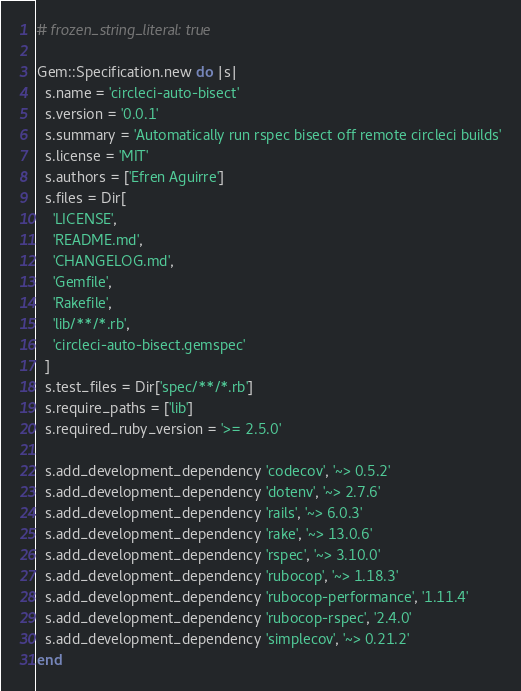Convert code to text. <code><loc_0><loc_0><loc_500><loc_500><_Ruby_># frozen_string_literal: true

Gem::Specification.new do |s|
  s.name = 'circleci-auto-bisect'
  s.version = '0.0.1'
  s.summary = 'Automatically run rspec bisect off remote circleci builds'
  s.license = 'MIT'
  s.authors = ['Efren Aguirre']
  s.files = Dir[
    'LICENSE',
    'README.md',
    'CHANGELOG.md',
    'Gemfile',
    'Rakefile',
    'lib/**/*.rb',
    'circleci-auto-bisect.gemspec'
  ]
  s.test_files = Dir['spec/**/*.rb']
  s.require_paths = ['lib']
  s.required_ruby_version = '>= 2.5.0'

  s.add_development_dependency 'codecov', '~> 0.5.2'
  s.add_development_dependency 'dotenv', '~> 2.7.6'
  s.add_development_dependency 'rails', '~> 6.0.3'
  s.add_development_dependency 'rake', '~> 13.0.6'
  s.add_development_dependency 'rspec', '~> 3.10.0'
  s.add_development_dependency 'rubocop', '~> 1.18.3'
  s.add_development_dependency 'rubocop-performance', '1.11.4'
  s.add_development_dependency 'rubocop-rspec', '2.4.0'
  s.add_development_dependency 'simplecov', '~> 0.21.2'
end
</code> 